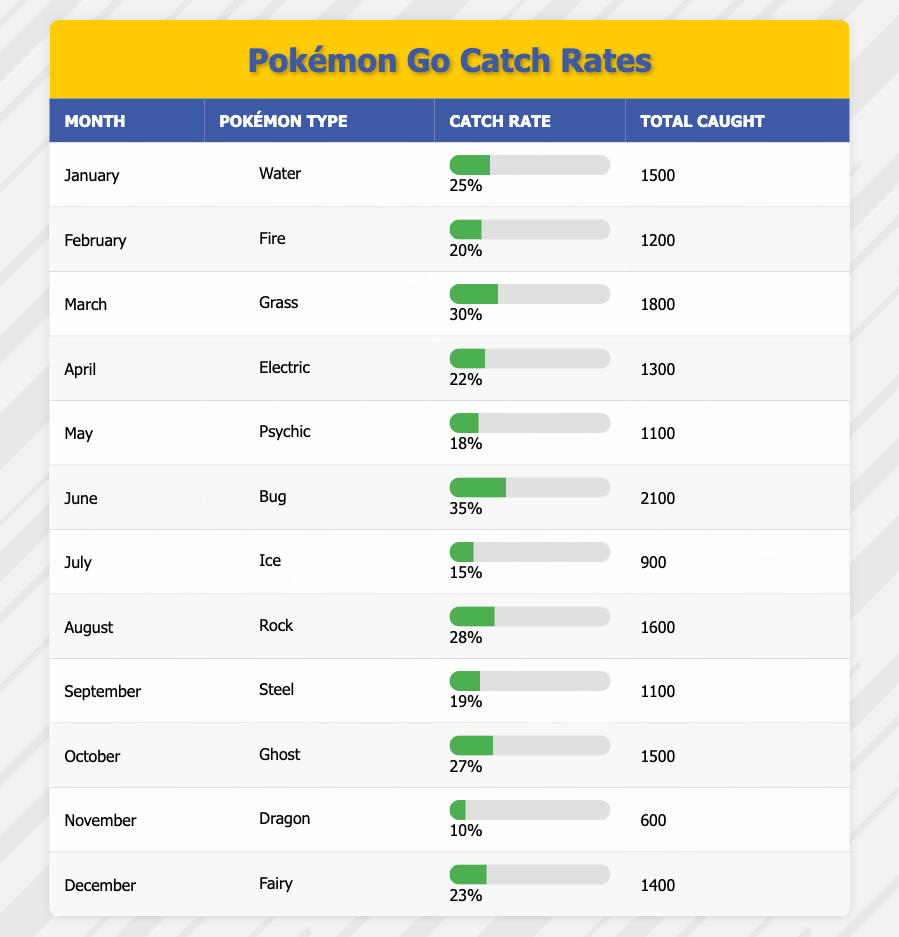What was the catch rate for Grass-type Pokémon in March? The table shows that in March, the catch rate for Grass-type Pokémon was listed under the "Catch Rate" column, which indicates a percentage of 30%.
Answer: 30% Which month had the highest total Pokémon caught? By examining the "Total Caught" column for each month, the highest value appears to be 2100 in June for Bug-type Pokémon.
Answer: June Was the catch rate for Psychic-type Pokémon lower than that for Water-type Pokémon? The catch rate for Water-type Pokémon in January is 25%, while for Psychic-type in May it is 18%. Since 18% is lower than 25%, the answer is yes.
Answer: Yes What is the average catch rate for all Pokémon types across the twelve months? To find the average, calculate the sum of all catch rates: (25 + 20 + 30 + 22 + 18 + 35 + 15 + 28 + 19 + 27 + 10 + 23) =  252. There are 12 months, so the average catch rate is 252/12 = 21%.
Answer: 21% In which month was the lowest number of total Pokémon caught? Looking at the "Total Caught" column, the lowest total caught is 600 in November, which corresponds to Dragon-type Pokémon.
Answer: November Did August have a higher catch rate than April? The catch rate in April for Electric is 22% and in August for Rock is 28%. Since 28% is greater than 22%, the answer is yes.
Answer: Yes How many more total Pokémon were caught in June than in November? The total caught in June is 2100 and in November is 600. The difference is 2100 - 600 = 1500.
Answer: 1500 Which Pokémon type had the catch rate of 15%? By examining the "Catch Rate" column, the catch rate of 15% corresponds to Ice-type Pokémon, which was caught in July.
Answer: Ice Which Pokémon type had the highest catch rate in the table? The catch rate of Bug-type Pokémon in June is 35%, which is the highest among all Pokémon types listed.
Answer: Bug 